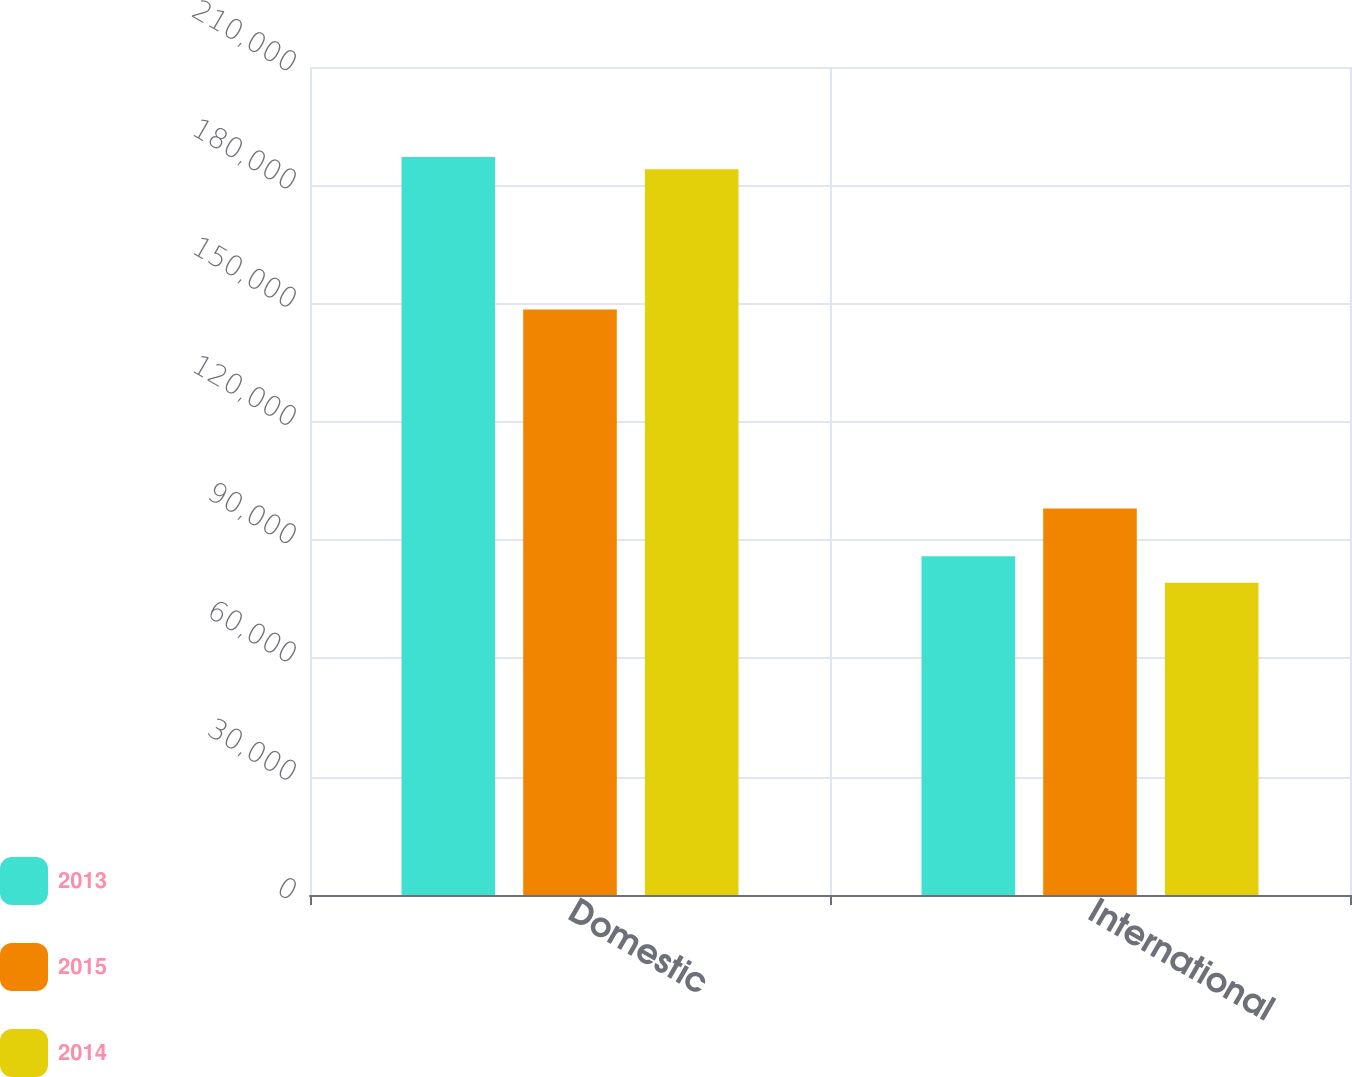<chart> <loc_0><loc_0><loc_500><loc_500><stacked_bar_chart><ecel><fcel>Domestic<fcel>International<nl><fcel>2013<fcel>187200<fcel>85941<nl><fcel>2015<fcel>148510<fcel>98045<nl><fcel>2014<fcel>184086<fcel>79175<nl></chart> 